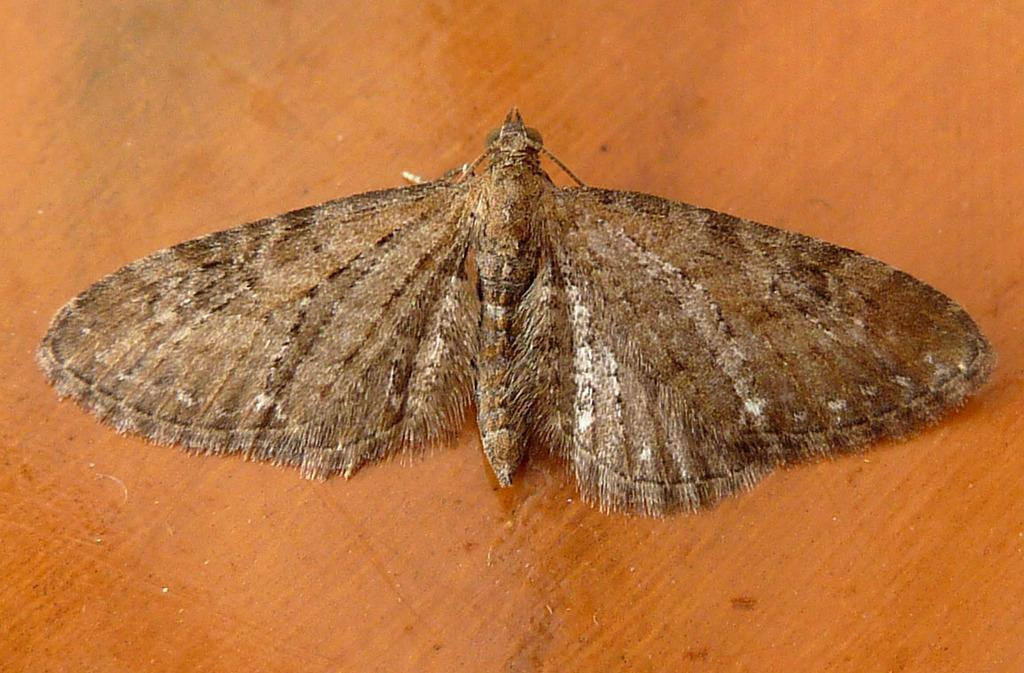What is the main subject of the image? The main subject of the image is a butterfly. Where is the butterfly located in the image? The butterfly is on a wooden surface. What type of war is being depicted in the image? There is no war depicted in the image; it features a butterfly on a wooden surface. How many geese are present in the image? There are no geese present in the image; it features a butterfly on a wooden surface. 